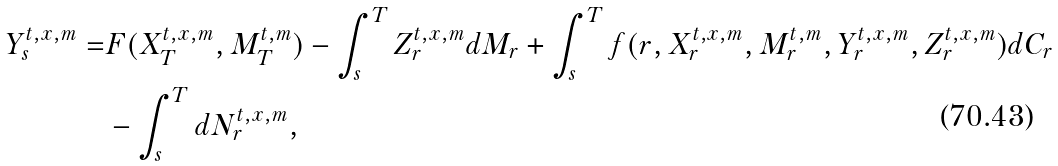Convert formula to latex. <formula><loc_0><loc_0><loc_500><loc_500>Y _ { s } ^ { t , x , m } = & F ( X _ { T } ^ { t , x , m } , M _ { T } ^ { t , m } ) - \int _ { s } ^ { T } Z _ { r } ^ { t , x , m } d M _ { r } + \int _ { s } ^ { T } f ( r , X _ { r } ^ { t , x , m } , M _ { r } ^ { t , m } , Y _ { r } ^ { t , x , m } , Z _ { r } ^ { t , x , m } ) d C _ { r } \\ & - \int _ { s } ^ { T } d N _ { r } ^ { t , x , m } ,</formula> 